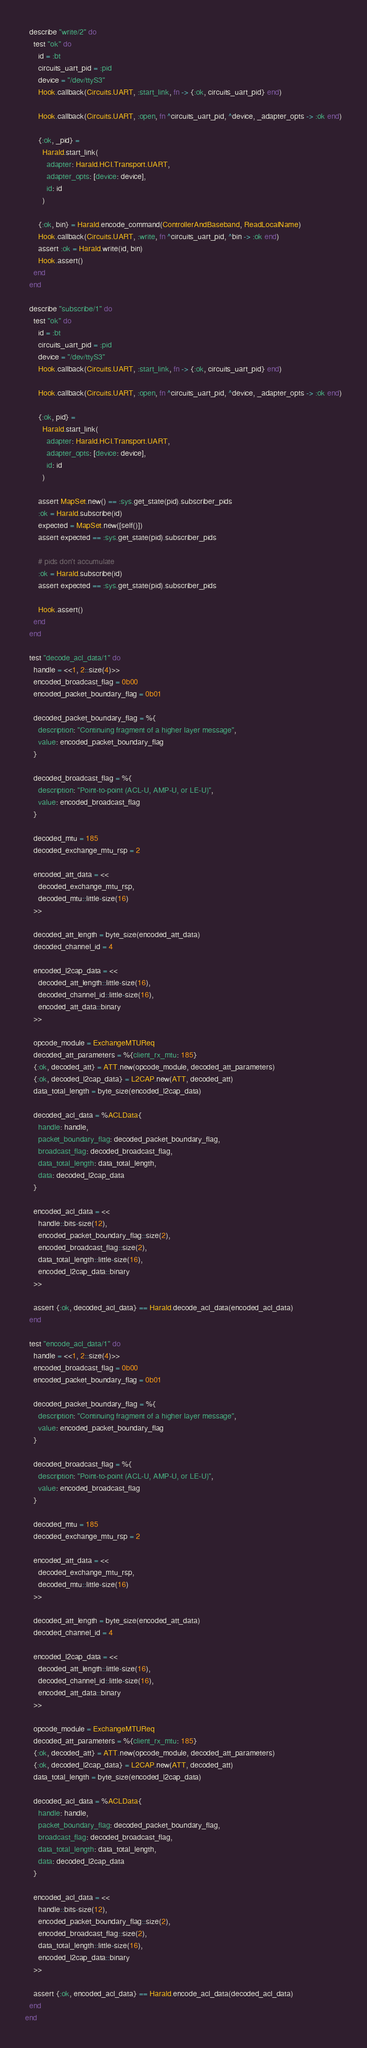<code> <loc_0><loc_0><loc_500><loc_500><_Elixir_>
  describe "write/2" do
    test "ok" do
      id = :bt
      circuits_uart_pid = :pid
      device = "/dev/ttyS3"
      Hook.callback(Circuits.UART, :start_link, fn -> {:ok, circuits_uart_pid} end)

      Hook.callback(Circuits.UART, :open, fn ^circuits_uart_pid, ^device, _adapter_opts -> :ok end)

      {:ok, _pid} =
        Harald.start_link(
          adapter: Harald.HCI.Transport.UART,
          adapter_opts: [device: device],
          id: id
        )

      {:ok, bin} = Harald.encode_command(ControllerAndBaseband, ReadLocalName)
      Hook.callback(Circuits.UART, :write, fn ^circuits_uart_pid, ^bin -> :ok end)
      assert :ok = Harald.write(id, bin)
      Hook.assert()
    end
  end

  describe "subscribe/1" do
    test "ok" do
      id = :bt
      circuits_uart_pid = :pid
      device = "/dev/ttyS3"
      Hook.callback(Circuits.UART, :start_link, fn -> {:ok, circuits_uart_pid} end)

      Hook.callback(Circuits.UART, :open, fn ^circuits_uart_pid, ^device, _adapter_opts -> :ok end)

      {:ok, pid} =
        Harald.start_link(
          adapter: Harald.HCI.Transport.UART,
          adapter_opts: [device: device],
          id: id
        )

      assert MapSet.new() == :sys.get_state(pid).subscriber_pids
      :ok = Harald.subscribe(id)
      expected = MapSet.new([self()])
      assert expected == :sys.get_state(pid).subscriber_pids

      # pids don't accumulate
      :ok = Harald.subscribe(id)
      assert expected == :sys.get_state(pid).subscriber_pids

      Hook.assert()
    end
  end

  test "decode_acl_data/1" do
    handle = <<1, 2::size(4)>>
    encoded_broadcast_flag = 0b00
    encoded_packet_boundary_flag = 0b01

    decoded_packet_boundary_flag = %{
      description: "Continuing fragment of a higher layer message",
      value: encoded_packet_boundary_flag
    }

    decoded_broadcast_flag = %{
      description: "Point-to-point (ACL-U, AMP-U, or LE-U)",
      value: encoded_broadcast_flag
    }

    decoded_mtu = 185
    decoded_exchange_mtu_rsp = 2

    encoded_att_data = <<
      decoded_exchange_mtu_rsp,
      decoded_mtu::little-size(16)
    >>

    decoded_att_length = byte_size(encoded_att_data)
    decoded_channel_id = 4

    encoded_l2cap_data = <<
      decoded_att_length::little-size(16),
      decoded_channel_id::little-size(16),
      encoded_att_data::binary
    >>

    opcode_module = ExchangeMTUReq
    decoded_att_parameters = %{client_rx_mtu: 185}
    {:ok, decoded_att} = ATT.new(opcode_module, decoded_att_parameters)
    {:ok, decoded_l2cap_data} = L2CAP.new(ATT, decoded_att)
    data_total_length = byte_size(encoded_l2cap_data)

    decoded_acl_data = %ACLData{
      handle: handle,
      packet_boundary_flag: decoded_packet_boundary_flag,
      broadcast_flag: decoded_broadcast_flag,
      data_total_length: data_total_length,
      data: decoded_l2cap_data
    }

    encoded_acl_data = <<
      handle::bits-size(12),
      encoded_packet_boundary_flag::size(2),
      encoded_broadcast_flag::size(2),
      data_total_length::little-size(16),
      encoded_l2cap_data::binary
    >>

    assert {:ok, decoded_acl_data} == Harald.decode_acl_data(encoded_acl_data)
  end

  test "encode_acl_data/1" do
    handle = <<1, 2::size(4)>>
    encoded_broadcast_flag = 0b00
    encoded_packet_boundary_flag = 0b01

    decoded_packet_boundary_flag = %{
      description: "Continuing fragment of a higher layer message",
      value: encoded_packet_boundary_flag
    }

    decoded_broadcast_flag = %{
      description: "Point-to-point (ACL-U, AMP-U, or LE-U)",
      value: encoded_broadcast_flag
    }

    decoded_mtu = 185
    decoded_exchange_mtu_rsp = 2

    encoded_att_data = <<
      decoded_exchange_mtu_rsp,
      decoded_mtu::little-size(16)
    >>

    decoded_att_length = byte_size(encoded_att_data)
    decoded_channel_id = 4

    encoded_l2cap_data = <<
      decoded_att_length::little-size(16),
      decoded_channel_id::little-size(16),
      encoded_att_data::binary
    >>

    opcode_module = ExchangeMTUReq
    decoded_att_parameters = %{client_rx_mtu: 185}
    {:ok, decoded_att} = ATT.new(opcode_module, decoded_att_parameters)
    {:ok, decoded_l2cap_data} = L2CAP.new(ATT, decoded_att)
    data_total_length = byte_size(encoded_l2cap_data)

    decoded_acl_data = %ACLData{
      handle: handle,
      packet_boundary_flag: decoded_packet_boundary_flag,
      broadcast_flag: decoded_broadcast_flag,
      data_total_length: data_total_length,
      data: decoded_l2cap_data
    }

    encoded_acl_data = <<
      handle::bits-size(12),
      encoded_packet_boundary_flag::size(2),
      encoded_broadcast_flag::size(2),
      data_total_length::little-size(16),
      encoded_l2cap_data::binary
    >>

    assert {:ok, encoded_acl_data} == Harald.encode_acl_data(decoded_acl_data)
  end
end
</code> 